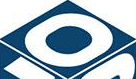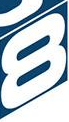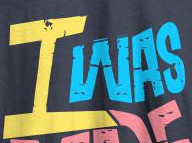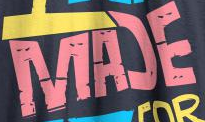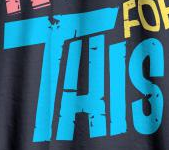What words can you see in these images in sequence, separated by a semicolon? 0; 8; IWAS; MAƆE; THIS 